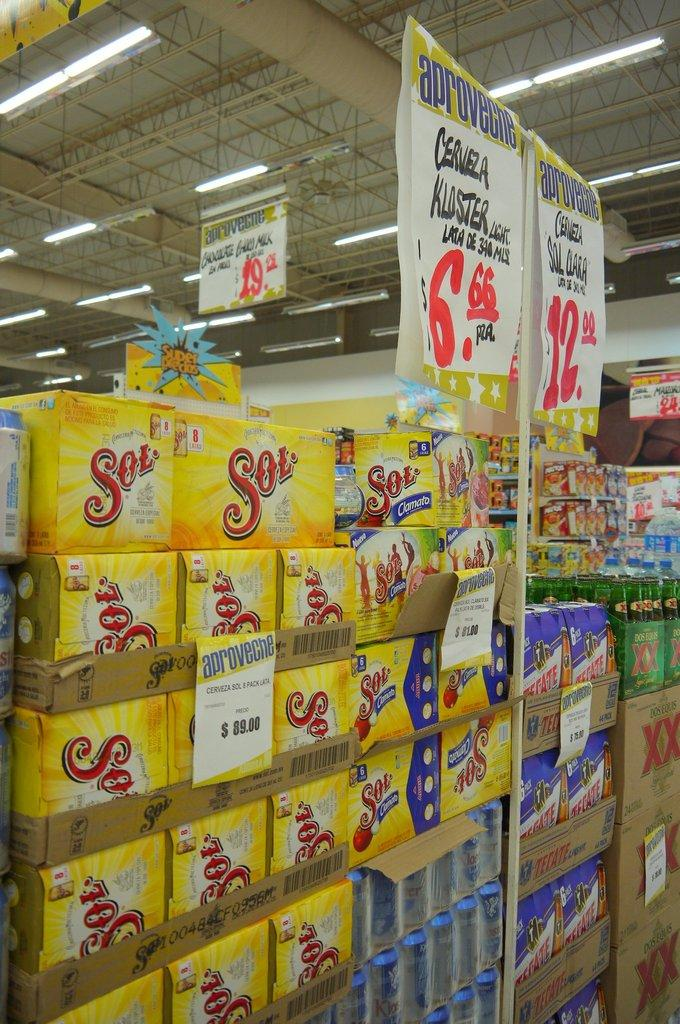<image>
Provide a brief description of the given image. Several yellow cases of Sol are stacked up at the store. 